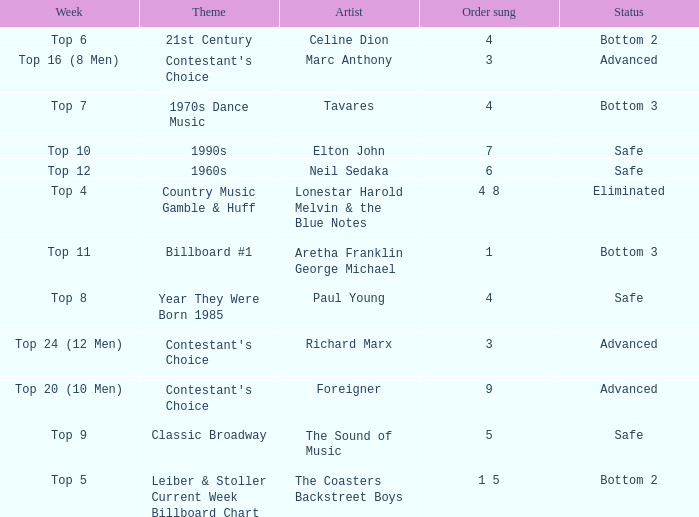What was the theme for the Top 11 week? Billboard #1. Would you be able to parse every entry in this table? {'header': ['Week', 'Theme', 'Artist', 'Order sung', 'Status'], 'rows': [['Top 6', '21st Century', 'Celine Dion', '4', 'Bottom 2'], ['Top 16 (8 Men)', "Contestant's Choice", 'Marc Anthony', '3', 'Advanced'], ['Top 7', '1970s Dance Music', 'Tavares', '4', 'Bottom 3'], ['Top 10', '1990s', 'Elton John', '7', 'Safe'], ['Top 12', '1960s', 'Neil Sedaka', '6', 'Safe'], ['Top 4', 'Country Music Gamble & Huff', 'Lonestar Harold Melvin & the Blue Notes', '4 8', 'Eliminated'], ['Top 11', 'Billboard #1', 'Aretha Franklin George Michael', '1', 'Bottom 3'], ['Top 8', 'Year They Were Born 1985', 'Paul Young', '4', 'Safe'], ['Top 24 (12 Men)', "Contestant's Choice", 'Richard Marx', '3', 'Advanced'], ['Top 20 (10 Men)', "Contestant's Choice", 'Foreigner', '9', 'Advanced'], ['Top 9', 'Classic Broadway', 'The Sound of Music', '5', 'Safe'], ['Top 5', 'Leiber & Stoller Current Week Billboard Chart', 'The Coasters Backstreet Boys', '1 5', 'Bottom 2']]} 